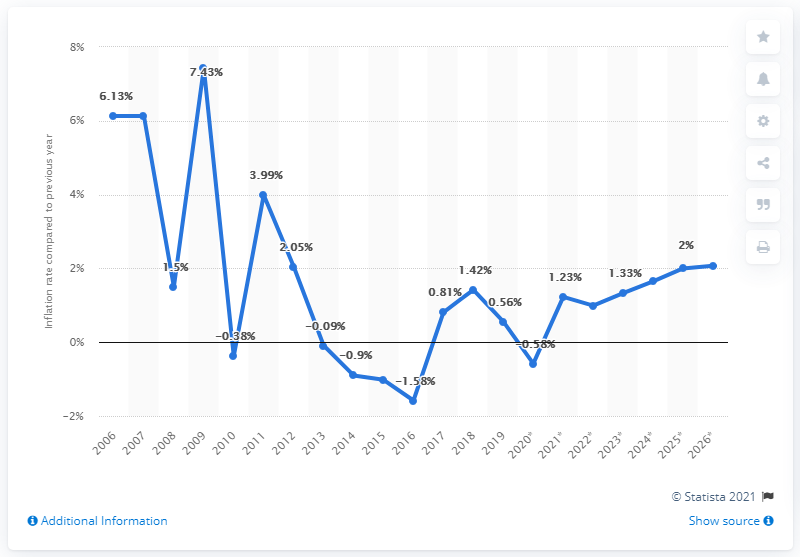Identify some key points in this picture. The average inflation rate in Bosnia & Herzegovina was in 2006. 